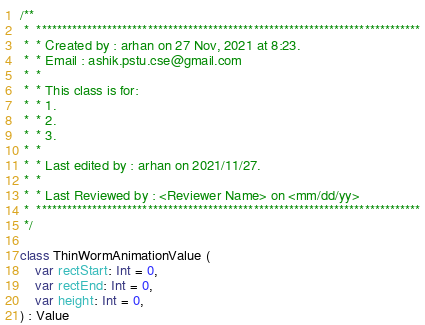<code> <loc_0><loc_0><loc_500><loc_500><_Kotlin_>/**
 *  ****************************************************************************
 *  * Created by : arhan on 27 Nov, 2021 at 8:23.
 *  * Email : ashik.pstu.cse@gmail.com
 *  *
 *  * This class is for:
 *  * 1.
 *  * 2.
 *  * 3.
 *  *
 *  * Last edited by : arhan on 2021/11/27.
 *  *
 *  * Last Reviewed by : <Reviewer Name> on <mm/dd/yy>
 *  ****************************************************************************
 */

class ThinWormAnimationValue (
    var rectStart: Int = 0,
    var rectEnd: Int = 0,
    var height: Int = 0,
) : Value</code> 